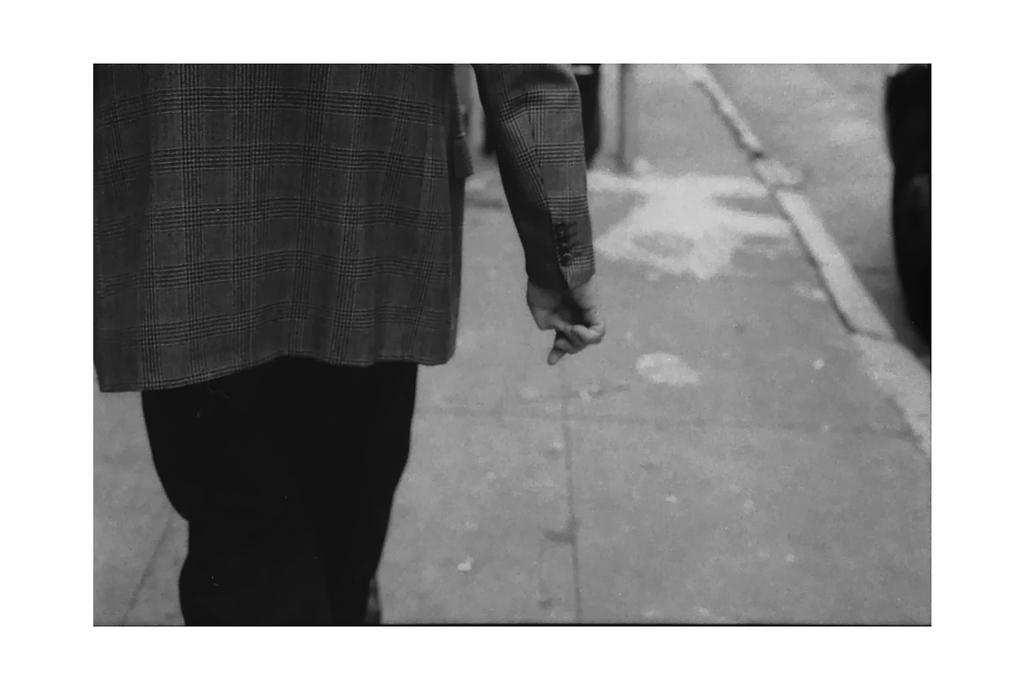What is the color scheme of the image? The image is black and white. Can you describe the person on the left side of the image? There is a person on the left side of the image, but their head is not visible. What can be seen in the background of the image? There are objects on the road and the footpath in the background of the image. What type of cheese is being used to gain approval in the image? There is no cheese or approval process present in the image. What thing is being used to gain approval in the image? There is no approval process or thing being used to gain approval in the image. 